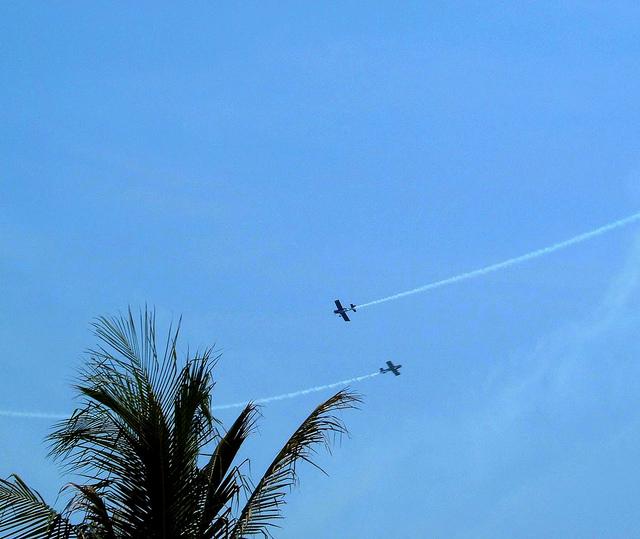Are the plane heading the same direction?
Quick response, please. No. What maneuver have the planes just executed?
Concise answer only. Fly by. What is the white line behind the two planes?
Quick response, please. Smoke. Is the blue of the sky a type called slate blue?
Give a very brief answer. No. Where is a vapor trail?
Be succinct. Sky. How many planes are here?
Short answer required. 2. What kind of clouds are in the sky?
Answer briefly. None. Is it winter?
Keep it brief. No. 